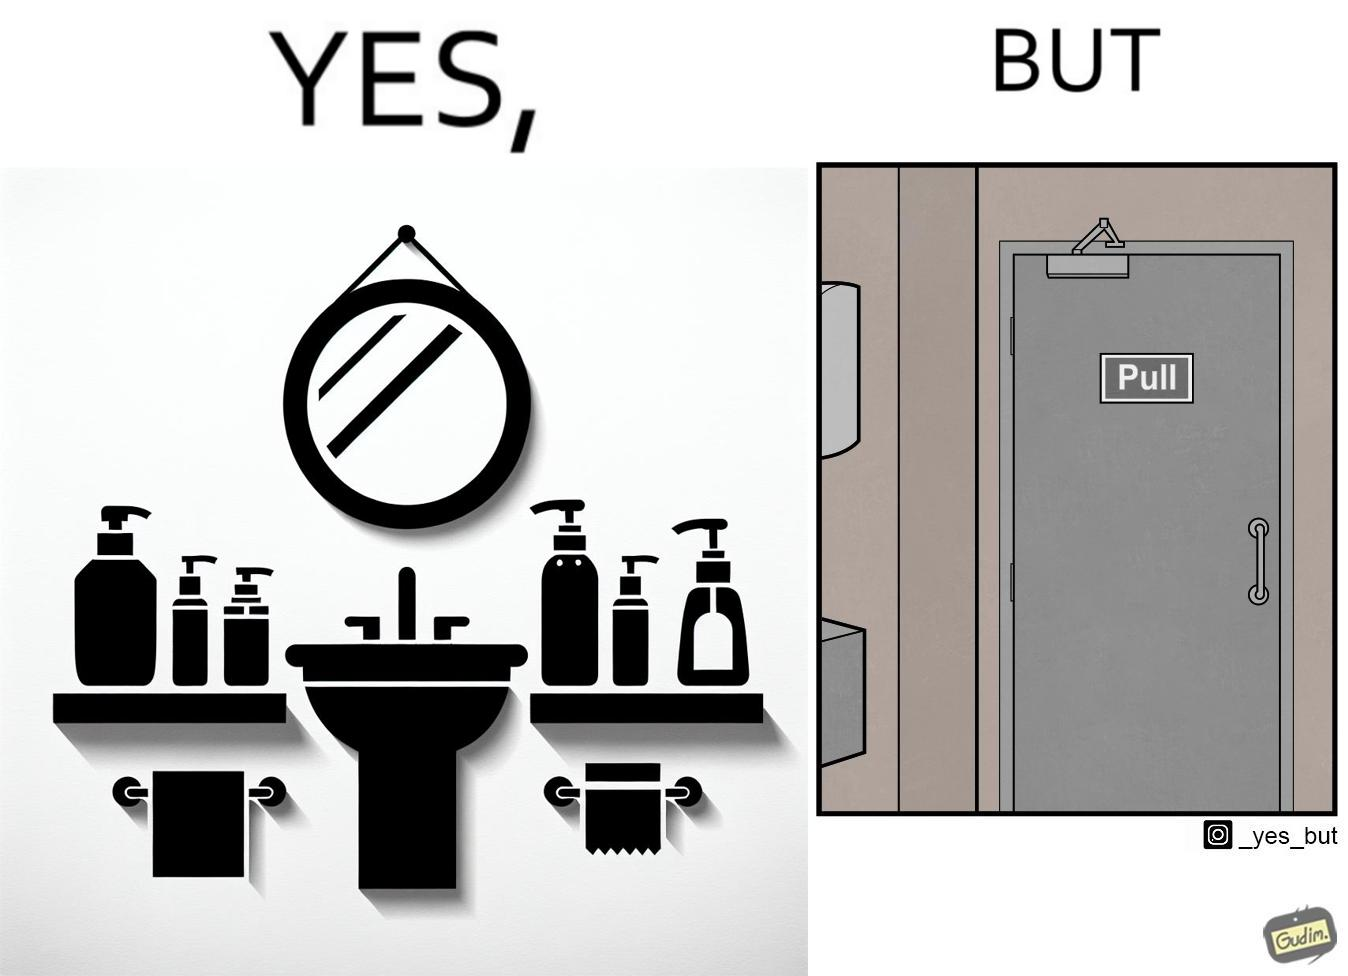Would you classify this image as satirical? Yes, this image is satirical. 